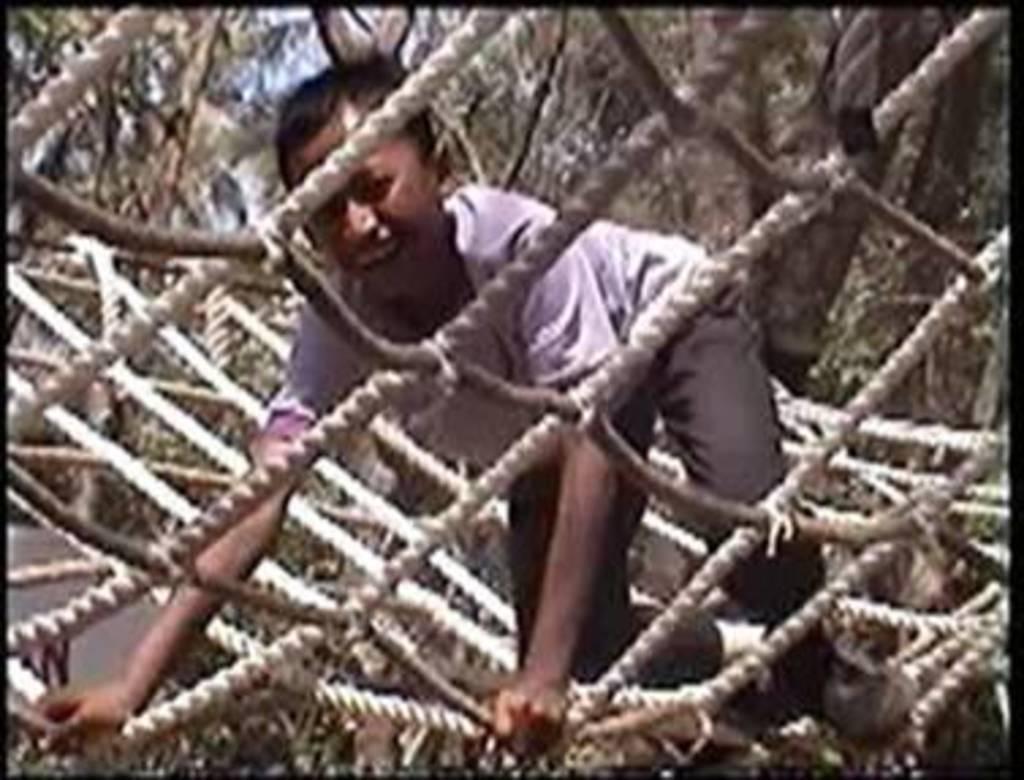Please provide a concise description of this image. A person is present on the net. There are trees at the back. 